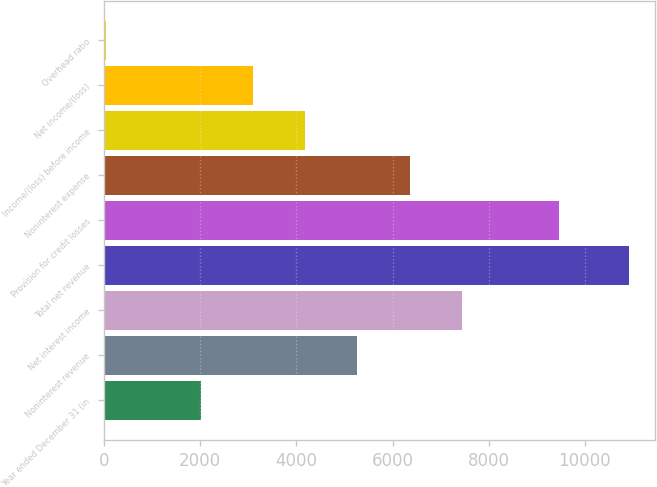Convert chart. <chart><loc_0><loc_0><loc_500><loc_500><bar_chart><fcel>Year ended December 31 (in<fcel>Noninterest revenue<fcel>Net interest income<fcel>Total net revenue<fcel>Provision for credit losses<fcel>Noninterest expense<fcel>Income/(loss) before income<fcel>Net income/(loss)<fcel>Overhead ratio<nl><fcel>2008<fcel>5267.8<fcel>7441<fcel>10910<fcel>9456<fcel>6354.4<fcel>4181.2<fcel>3094.6<fcel>44<nl></chart> 